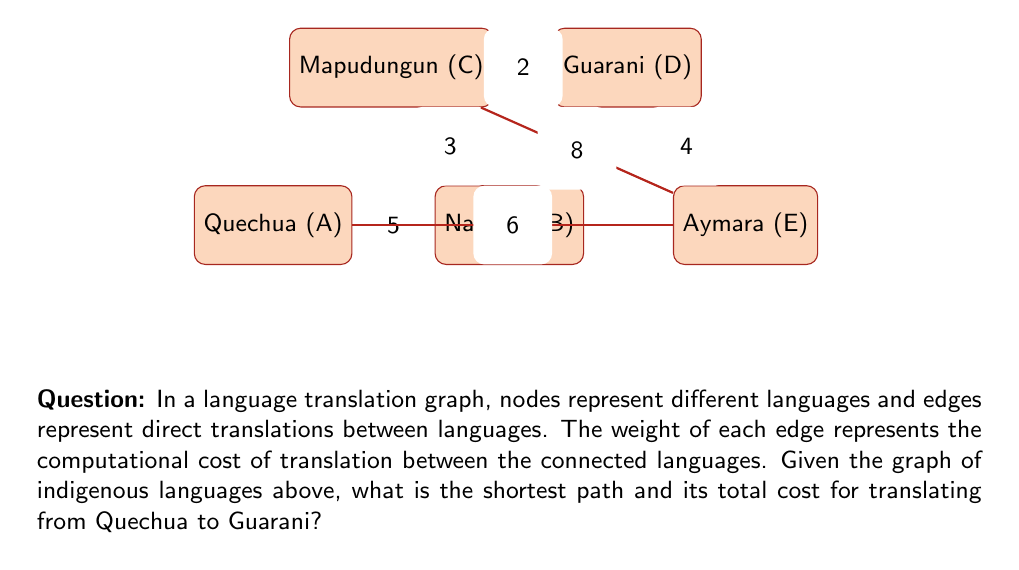Solve this math problem. To solve this problem, we can use Dijkstra's algorithm to find the shortest path between Quechua (A) and Guarani (D). Let's go through the steps:

1) Initialize:
   - Set distance to A (Quechua) as 0 and all others as infinity.
   - Set all nodes as unvisited.

2) Start from A (Quechua):
   - Update distances: B = 5, E = 6
   - Mark A as visited

3) Choose the smallest unvisited distance (B = 5):
   - Update distances: C = 8 (5+3), D = 12 (5+7)
   - Mark B as visited

4) Choose the smallest unvisited distance (E = 6):
   - Update distances: D = 10 (6+4)
   - Mark E as visited

5) Choose the smallest unvisited distance (C = 8):
   - Update distances: D = 10 (unchanged)
   - Mark C as visited

6) The shortest path to D (Guarani) is found: A -> B -> C -> D

7) Calculate the total cost:
   $$ \text{Total Cost} = AB + BC + CD = 5 + 3 + 2 = 10 $$

Therefore, the shortest path from Quechua to Guarani is Quechua -> Nahuatl -> Mapudungun -> Guarani, with a total cost of 10.
Answer: Path: Quechua -> Nahuatl -> Mapudungun -> Guarani; Cost: 10 